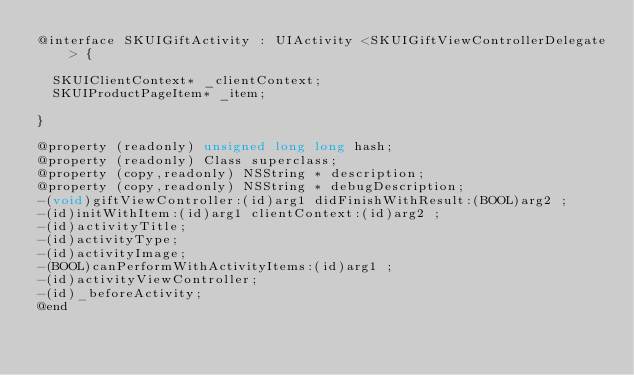<code> <loc_0><loc_0><loc_500><loc_500><_C_>@interface SKUIGiftActivity : UIActivity <SKUIGiftViewControllerDelegate> {

	SKUIClientContext* _clientContext;
	SKUIProductPageItem* _item;

}

@property (readonly) unsigned long long hash; 
@property (readonly) Class superclass; 
@property (copy,readonly) NSString * description; 
@property (copy,readonly) NSString * debugDescription; 
-(void)giftViewController:(id)arg1 didFinishWithResult:(BOOL)arg2 ;
-(id)initWithItem:(id)arg1 clientContext:(id)arg2 ;
-(id)activityTitle;
-(id)activityType;
-(id)activityImage;
-(BOOL)canPerformWithActivityItems:(id)arg1 ;
-(id)activityViewController;
-(id)_beforeActivity;
@end

</code> 